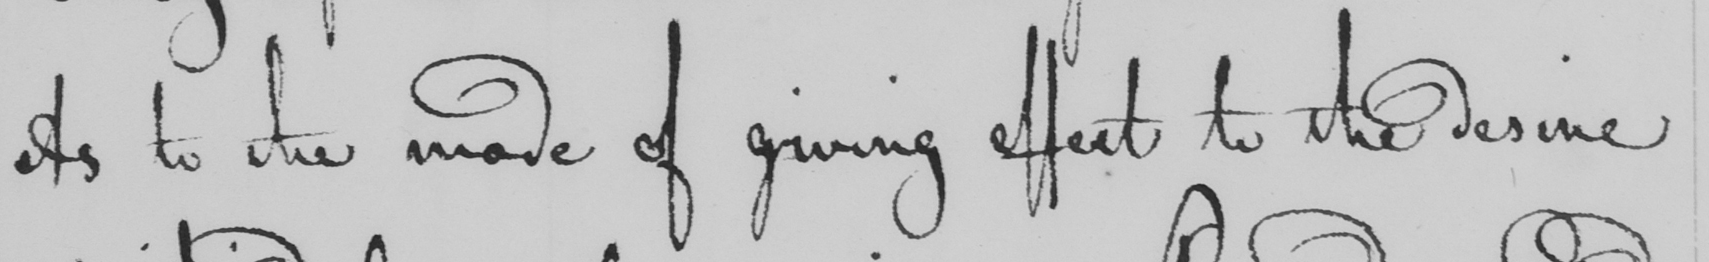What is written in this line of handwriting? As to the mode of giving effect to the desire 